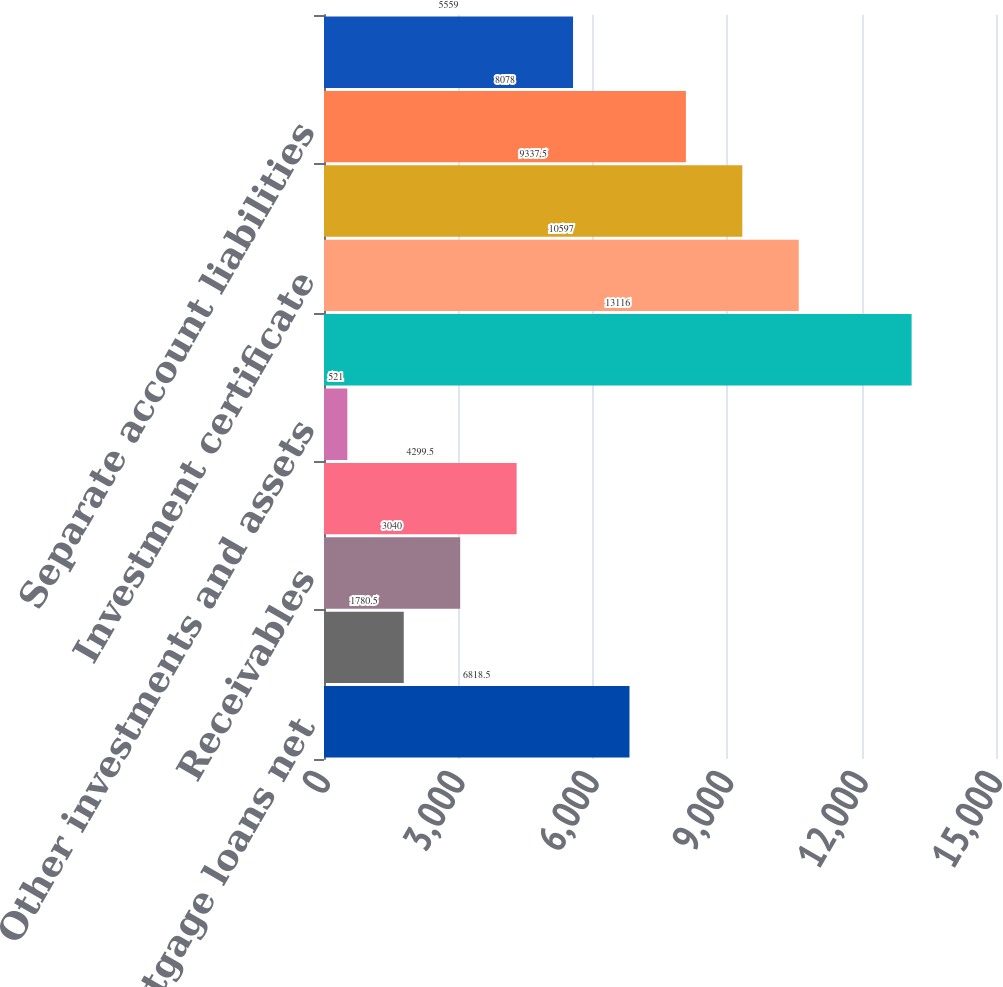<chart> <loc_0><loc_0><loc_500><loc_500><bar_chart><fcel>Commercial mortgage loans net<fcel>Policy loans<fcel>Receivables<fcel>Restricted and segregated cash<fcel>Other investments and assets<fcel>Future policy benefits and<fcel>Investment certificate<fcel>Banking and brokerage customer<fcel>Separate account liabilities<fcel>Debt and other liabilities<nl><fcel>6818.5<fcel>1780.5<fcel>3040<fcel>4299.5<fcel>521<fcel>13116<fcel>10597<fcel>9337.5<fcel>8078<fcel>5559<nl></chart> 